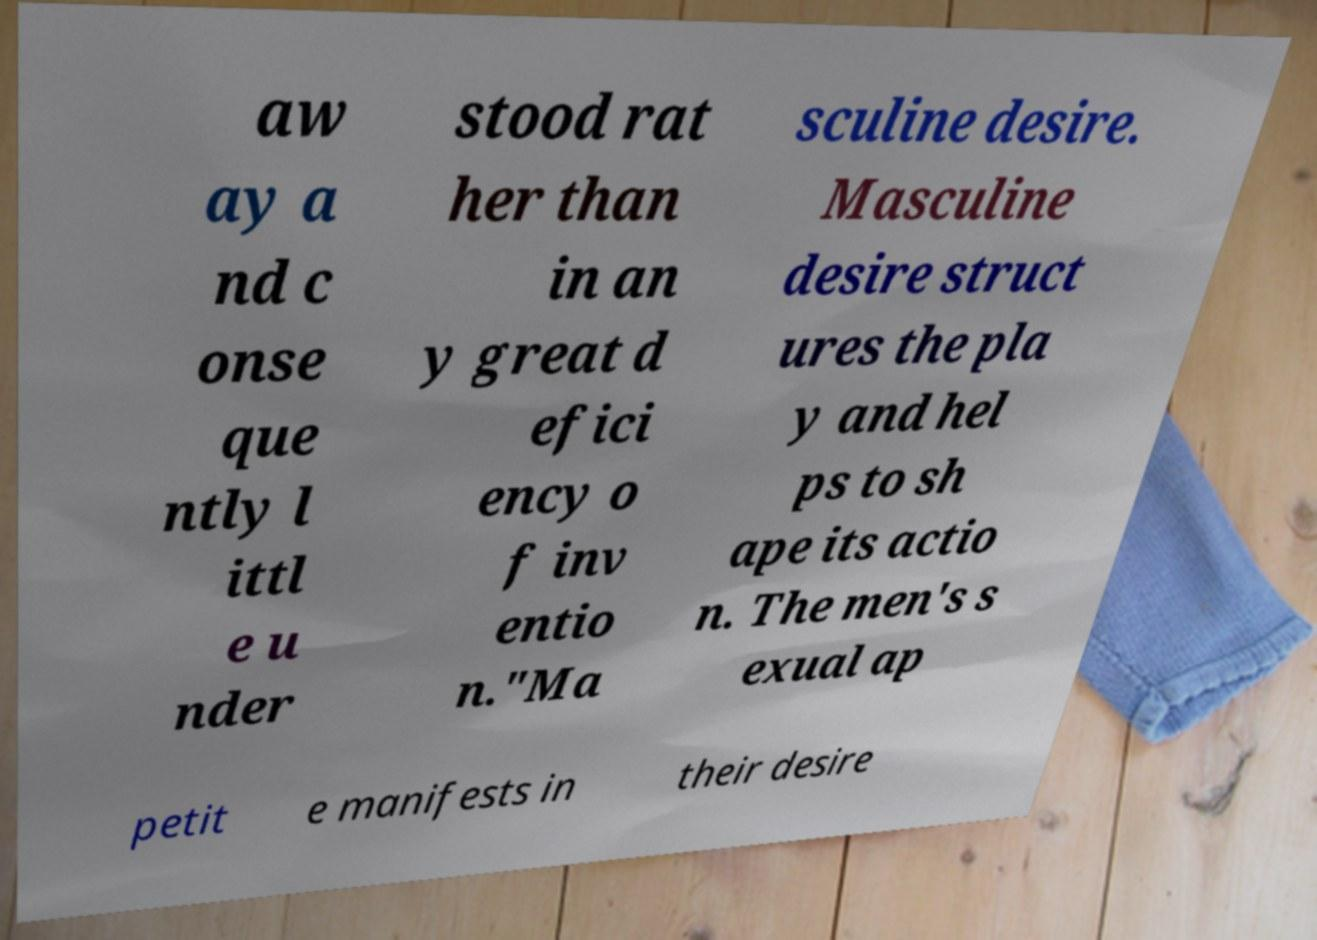Can you accurately transcribe the text from the provided image for me? aw ay a nd c onse que ntly l ittl e u nder stood rat her than in an y great d efici ency o f inv entio n."Ma sculine desire. Masculine desire struct ures the pla y and hel ps to sh ape its actio n. The men's s exual ap petit e manifests in their desire 